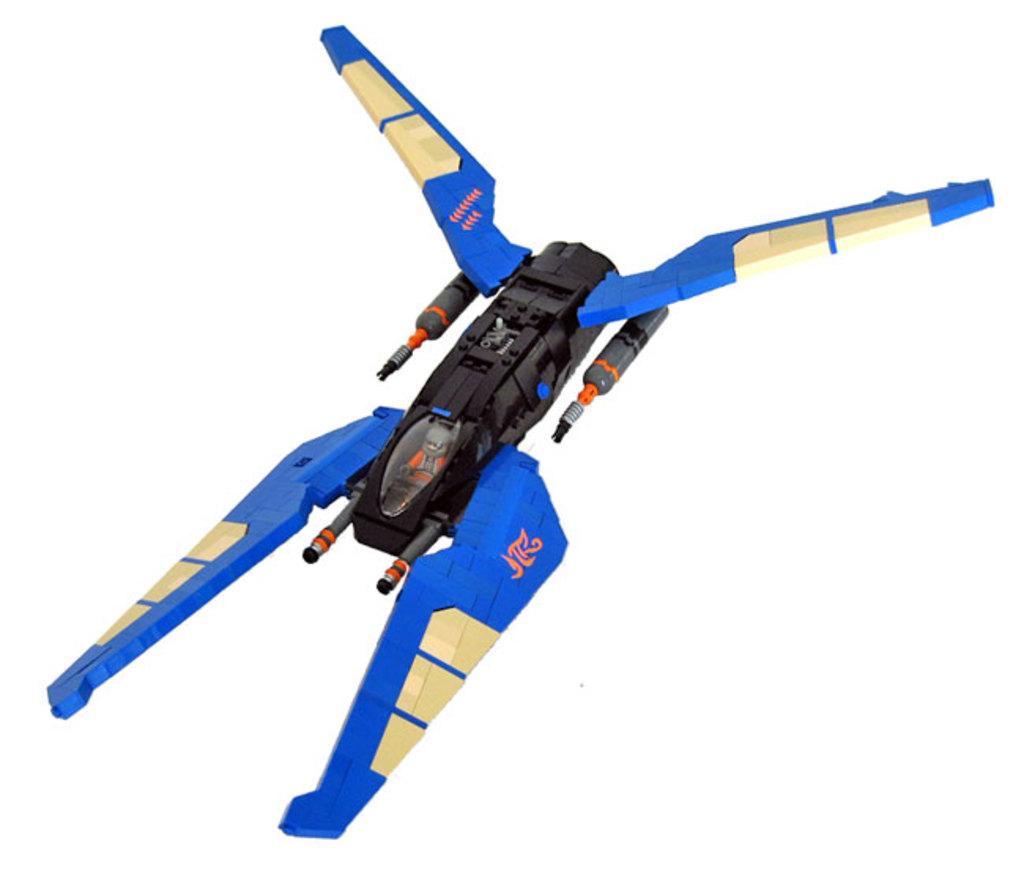Please provide a concise description of this image. In this image I can see a toy. The background of the image is white in color. 